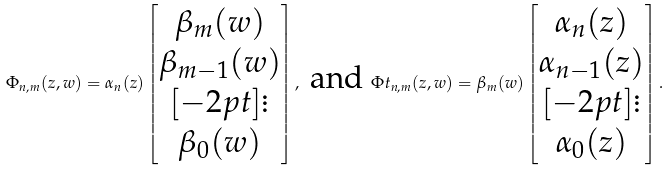Convert formula to latex. <formula><loc_0><loc_0><loc_500><loc_500>\Phi _ { n , m } ( z , w ) = \alpha _ { n } ( z ) \left [ \begin{matrix} \beta _ { m } ( w ) \\ \beta _ { m - 1 } ( w ) \\ [ - 2 p t ] \vdots \\ \beta _ { 0 } ( w ) \end{matrix} \right ] , \text { and } \Phi t _ { n , m } ( z , w ) = \beta _ { m } ( w ) \left [ \begin{matrix} \alpha _ { n } ( z ) \\ \alpha _ { n - 1 } ( z ) \\ [ - 2 p t ] \vdots \\ \alpha _ { 0 } ( z ) \end{matrix} \right ] .</formula> 